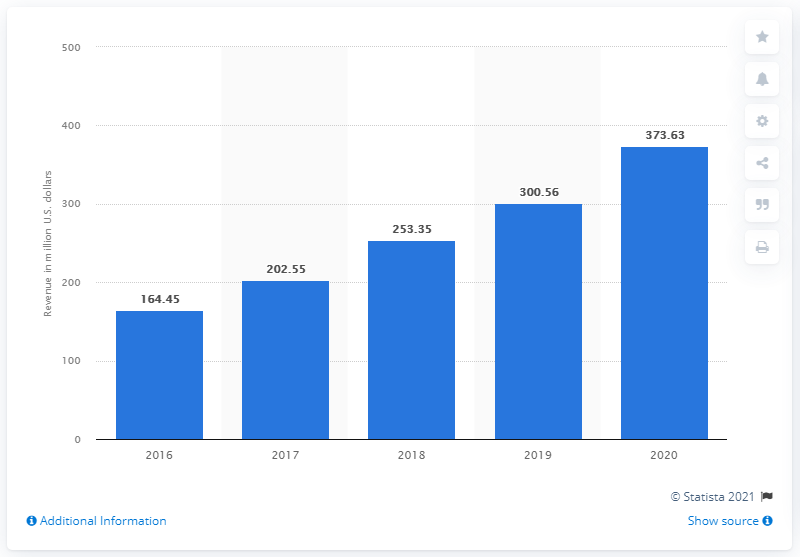Give some essential details in this illustration. Upwork generated $373.63 million in revenue in the United States in 2020. 